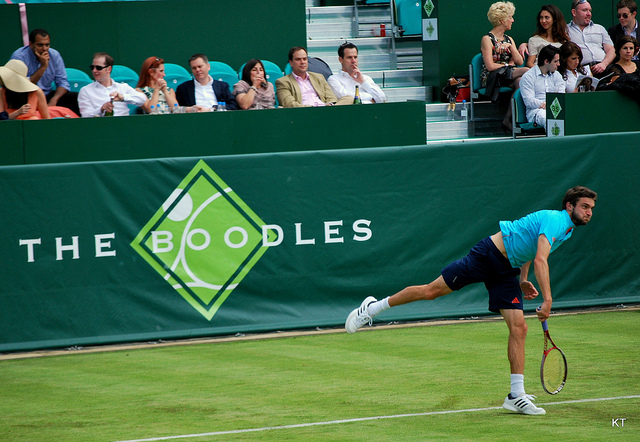Identify the text displayed in this image. THE BOODLES KT 